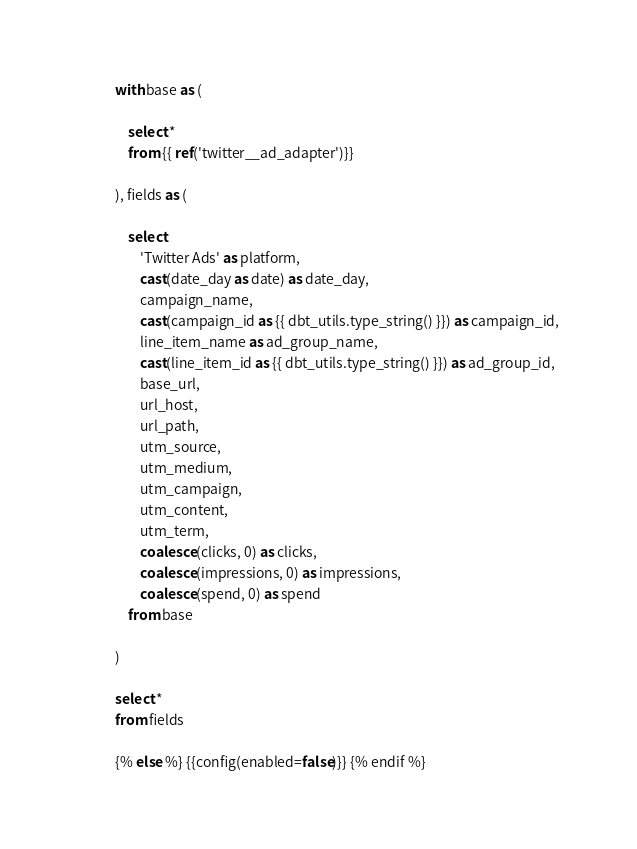Convert code to text. <code><loc_0><loc_0><loc_500><loc_500><_SQL_>
with base as (

    select *
    from {{ ref('twitter__ad_adapter')}}

), fields as (

    select
        'Twitter Ads' as platform,
        cast(date_day as date) as date_day,
        campaign_name,
        cast(campaign_id as {{ dbt_utils.type_string() }}) as campaign_id,
        line_item_name as ad_group_name,
        cast(line_item_id as {{ dbt_utils.type_string() }}) as ad_group_id,
        base_url,
        url_host,
        url_path,
        utm_source,
        utm_medium,
        utm_campaign,
        utm_content,
        utm_term,
        coalesce(clicks, 0) as clicks,
        coalesce(impressions, 0) as impressions,
        coalesce(spend, 0) as spend
    from base

)

select *
from fields

{% else %} {{config(enabled=false)}} {% endif %}
</code> 